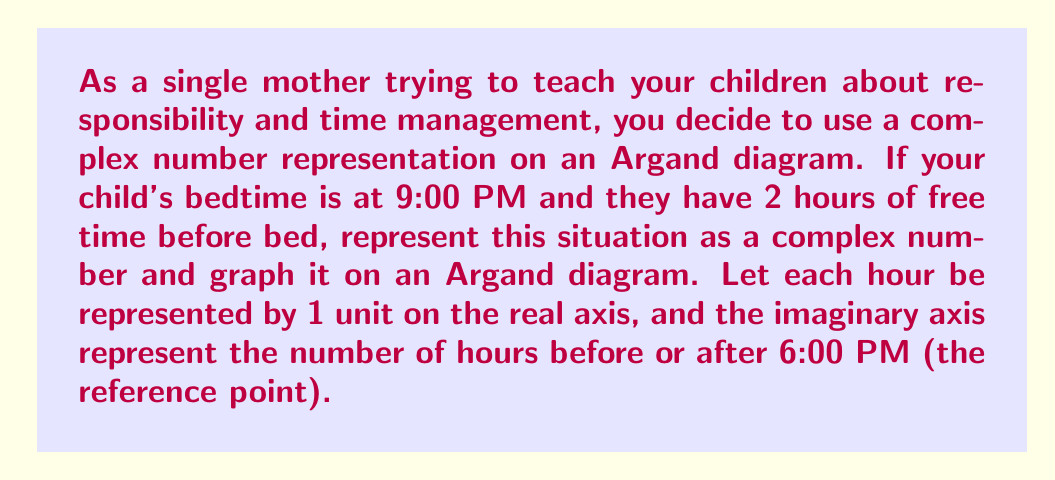Can you answer this question? Let's approach this step-by-step:

1) First, we need to establish our reference point. We're using 6:00 PM as our origin (0,0) on the Argand diagram.

2) The real part of our complex number will represent the number of hours of free time: 2 hours.

3) The imaginary part will represent the time of the event (bedtime) in relation to 6:00 PM:
   9:00 PM is 3 hours after 6:00 PM, so this will be represented by 3i.

4) Therefore, our complex number is $z = 2 + 3i$.

5) To graph this on an Argand diagram:
   - The real part (2) is plotted on the horizontal axis.
   - The imaginary part (3) is plotted on the vertical axis.

Here's how we would represent this graphically:

[asy]
import graph;
size(200);
real[] tickvals={-3,-2,-1,1,2,3};
string[] ticklabels={"3PM","4PM","5PM","7PM","8PM","9PM"};
xaxis("Real (hours of free time)",Ticks(tickvals, ticklabels));
yaxis("Imaginary (hours from 6PM)",Ticks(tickvals));
dot((2,3),red);
label("2 + 3i",(2,3),NE);
draw((0,0)--(2,3),blue,Arrow);
[/asy]

This diagram visually represents your child's 2 hours of free time before their 9:00 PM bedtime.
Answer: $z = 2 + 3i$, graphed as a point at (2,3) on the Argand diagram. 